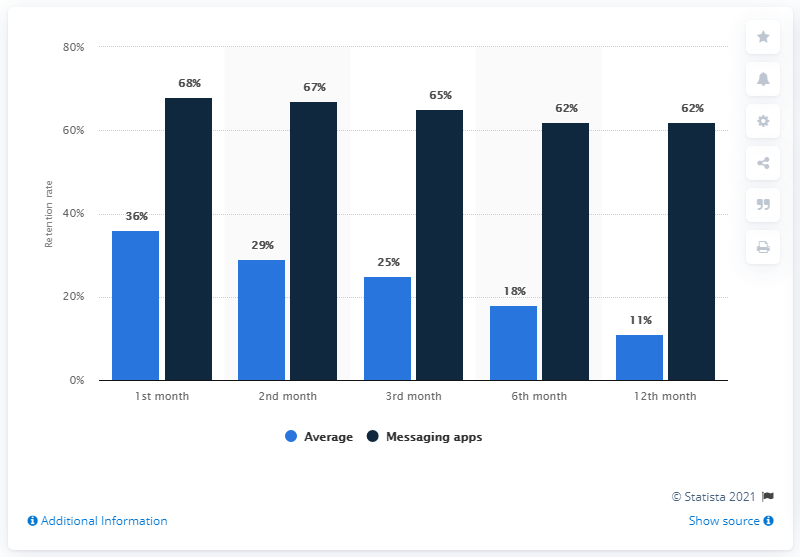Identify some key points in this picture. The average app retention rate at this point was 11%. 